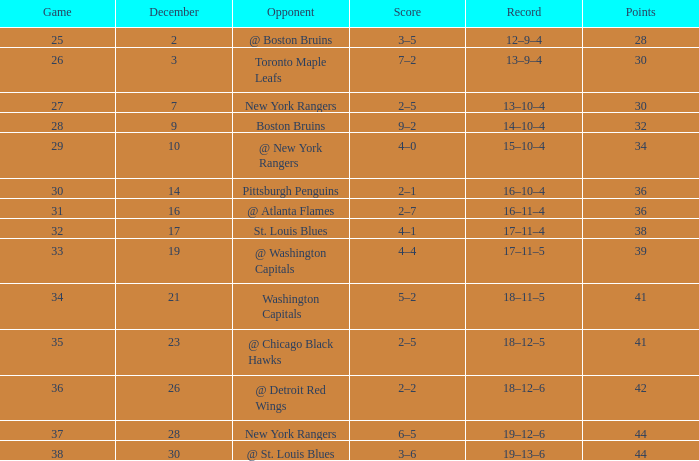In which game is the score above 32, points below 42, december more than 19, and the record is 18-12-5? 2–5. Would you mind parsing the complete table? {'header': ['Game', 'December', 'Opponent', 'Score', 'Record', 'Points'], 'rows': [['25', '2', '@ Boston Bruins', '3–5', '12–9–4', '28'], ['26', '3', 'Toronto Maple Leafs', '7–2', '13–9–4', '30'], ['27', '7', 'New York Rangers', '2–5', '13–10–4', '30'], ['28', '9', 'Boston Bruins', '9–2', '14–10–4', '32'], ['29', '10', '@ New York Rangers', '4–0', '15–10–4', '34'], ['30', '14', 'Pittsburgh Penguins', '2–1', '16–10–4', '36'], ['31', '16', '@ Atlanta Flames', '2–7', '16–11–4', '36'], ['32', '17', 'St. Louis Blues', '4–1', '17–11–4', '38'], ['33', '19', '@ Washington Capitals', '4–4', '17–11–5', '39'], ['34', '21', 'Washington Capitals', '5–2', '18–11–5', '41'], ['35', '23', '@ Chicago Black Hawks', '2–5', '18–12–5', '41'], ['36', '26', '@ Detroit Red Wings', '2–2', '18–12–6', '42'], ['37', '28', 'New York Rangers', '6–5', '19–12–6', '44'], ['38', '30', '@ St. Louis Blues', '3–6', '19–13–6', '44']]} 